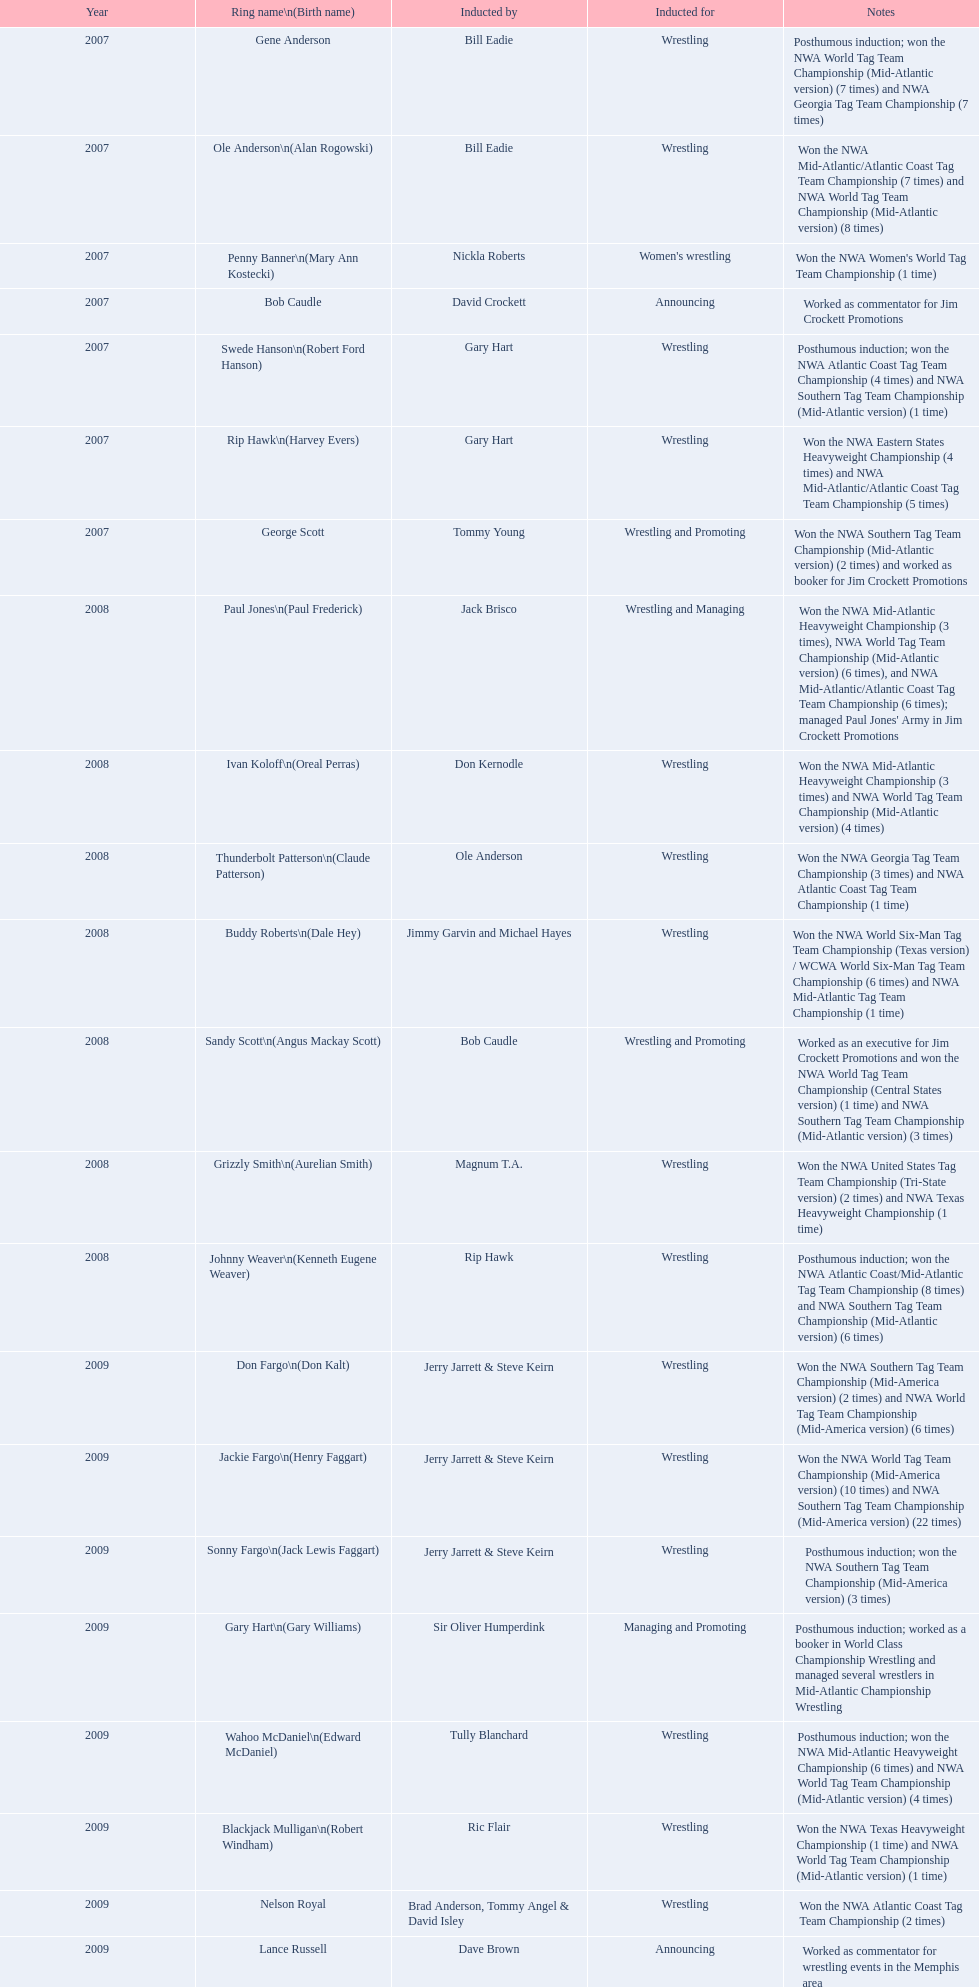Who was the announcer inducted into the hall of heroes in 2007? Bob Caudle. Who was the next announcer to be inducted? Lance Russell. What were the entire wrestler's arena names? Gene Anderson, Ole Anderson\n(Alan Rogowski), Penny Banner\n(Mary Ann Kostecki), Bob Caudle, Swede Hanson\n(Robert Ford Hanson), Rip Hawk\n(Harvey Evers), George Scott, Paul Jones\n(Paul Frederick), Ivan Koloff\n(Oreal Perras), Thunderbolt Patterson\n(Claude Patterson), Buddy Roberts\n(Dale Hey), Sandy Scott\n(Angus Mackay Scott), Grizzly Smith\n(Aurelian Smith), Johnny Weaver\n(Kenneth Eugene Weaver), Don Fargo\n(Don Kalt), Jackie Fargo\n(Henry Faggart), Sonny Fargo\n(Jack Lewis Faggart), Gary Hart\n(Gary Williams), Wahoo McDaniel\n(Edward McDaniel), Blackjack Mulligan\n(Robert Windham), Nelson Royal, Lance Russell. Apart from bob caudle, who served as an announcer? Lance Russell. 